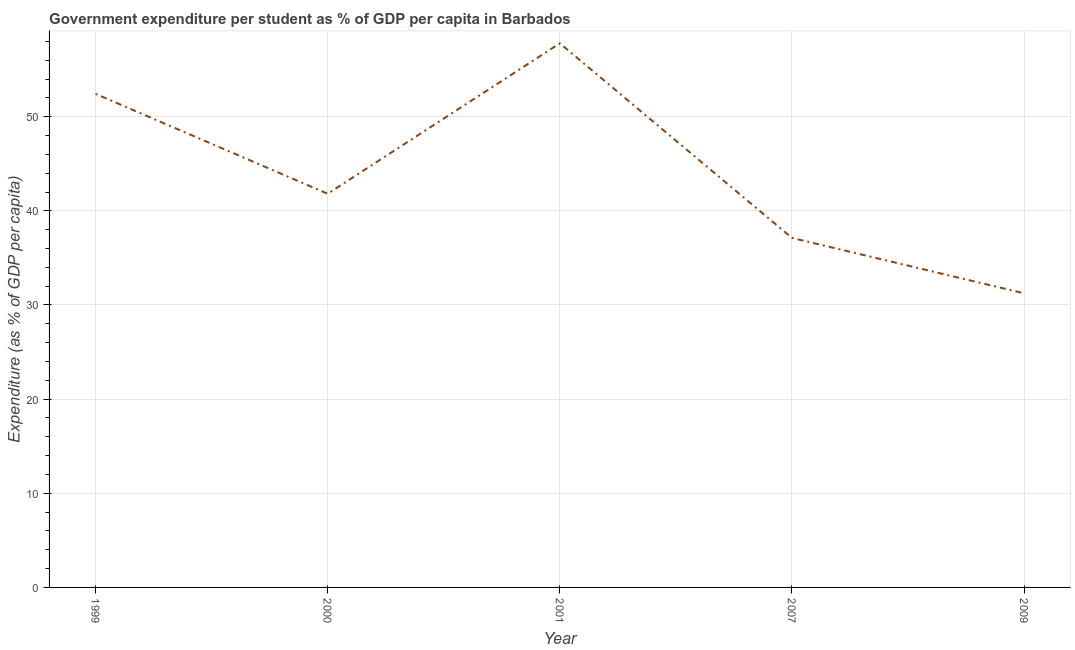What is the government expenditure per student in 2009?
Offer a terse response. 31.24. Across all years, what is the maximum government expenditure per student?
Your answer should be compact. 57.8. Across all years, what is the minimum government expenditure per student?
Your answer should be compact. 31.24. In which year was the government expenditure per student maximum?
Provide a succinct answer. 2001. What is the sum of the government expenditure per student?
Your answer should be compact. 220.4. What is the difference between the government expenditure per student in 2001 and 2007?
Provide a short and direct response. 20.67. What is the average government expenditure per student per year?
Your response must be concise. 44.08. What is the median government expenditure per student?
Give a very brief answer. 41.82. In how many years, is the government expenditure per student greater than 38 %?
Your response must be concise. 3. What is the ratio of the government expenditure per student in 1999 to that in 2007?
Your answer should be very brief. 1.41. What is the difference between the highest and the second highest government expenditure per student?
Make the answer very short. 5.37. Is the sum of the government expenditure per student in 2001 and 2007 greater than the maximum government expenditure per student across all years?
Ensure brevity in your answer.  Yes. What is the difference between the highest and the lowest government expenditure per student?
Keep it short and to the point. 26.55. Does the government expenditure per student monotonically increase over the years?
Offer a very short reply. No. How many lines are there?
Offer a very short reply. 1. How many years are there in the graph?
Provide a short and direct response. 5. Are the values on the major ticks of Y-axis written in scientific E-notation?
Ensure brevity in your answer.  No. Does the graph contain any zero values?
Make the answer very short. No. Does the graph contain grids?
Your answer should be compact. Yes. What is the title of the graph?
Give a very brief answer. Government expenditure per student as % of GDP per capita in Barbados. What is the label or title of the Y-axis?
Your answer should be compact. Expenditure (as % of GDP per capita). What is the Expenditure (as % of GDP per capita) in 1999?
Ensure brevity in your answer.  52.43. What is the Expenditure (as % of GDP per capita) in 2000?
Keep it short and to the point. 41.82. What is the Expenditure (as % of GDP per capita) in 2001?
Your response must be concise. 57.8. What is the Expenditure (as % of GDP per capita) of 2007?
Offer a terse response. 37.12. What is the Expenditure (as % of GDP per capita) in 2009?
Your answer should be compact. 31.24. What is the difference between the Expenditure (as % of GDP per capita) in 1999 and 2000?
Make the answer very short. 10.61. What is the difference between the Expenditure (as % of GDP per capita) in 1999 and 2001?
Your answer should be compact. -5.37. What is the difference between the Expenditure (as % of GDP per capita) in 1999 and 2007?
Give a very brief answer. 15.3. What is the difference between the Expenditure (as % of GDP per capita) in 1999 and 2009?
Offer a very short reply. 21.18. What is the difference between the Expenditure (as % of GDP per capita) in 2000 and 2001?
Make the answer very short. -15.98. What is the difference between the Expenditure (as % of GDP per capita) in 2000 and 2007?
Provide a short and direct response. 4.69. What is the difference between the Expenditure (as % of GDP per capita) in 2000 and 2009?
Ensure brevity in your answer.  10.57. What is the difference between the Expenditure (as % of GDP per capita) in 2001 and 2007?
Offer a terse response. 20.67. What is the difference between the Expenditure (as % of GDP per capita) in 2001 and 2009?
Your answer should be compact. 26.55. What is the difference between the Expenditure (as % of GDP per capita) in 2007 and 2009?
Offer a very short reply. 5.88. What is the ratio of the Expenditure (as % of GDP per capita) in 1999 to that in 2000?
Make the answer very short. 1.25. What is the ratio of the Expenditure (as % of GDP per capita) in 1999 to that in 2001?
Your answer should be very brief. 0.91. What is the ratio of the Expenditure (as % of GDP per capita) in 1999 to that in 2007?
Make the answer very short. 1.41. What is the ratio of the Expenditure (as % of GDP per capita) in 1999 to that in 2009?
Ensure brevity in your answer.  1.68. What is the ratio of the Expenditure (as % of GDP per capita) in 2000 to that in 2001?
Offer a terse response. 0.72. What is the ratio of the Expenditure (as % of GDP per capita) in 2000 to that in 2007?
Your answer should be very brief. 1.13. What is the ratio of the Expenditure (as % of GDP per capita) in 2000 to that in 2009?
Offer a very short reply. 1.34. What is the ratio of the Expenditure (as % of GDP per capita) in 2001 to that in 2007?
Make the answer very short. 1.56. What is the ratio of the Expenditure (as % of GDP per capita) in 2001 to that in 2009?
Offer a terse response. 1.85. What is the ratio of the Expenditure (as % of GDP per capita) in 2007 to that in 2009?
Offer a very short reply. 1.19. 